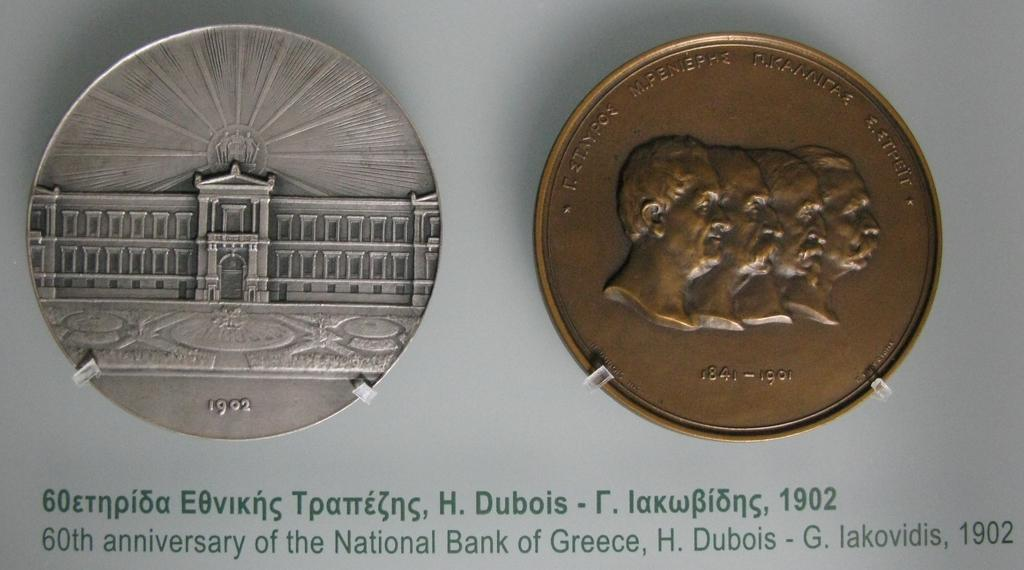<image>
Describe the image concisely. Coins for the 60th anniversary of the National Bank of Greece 